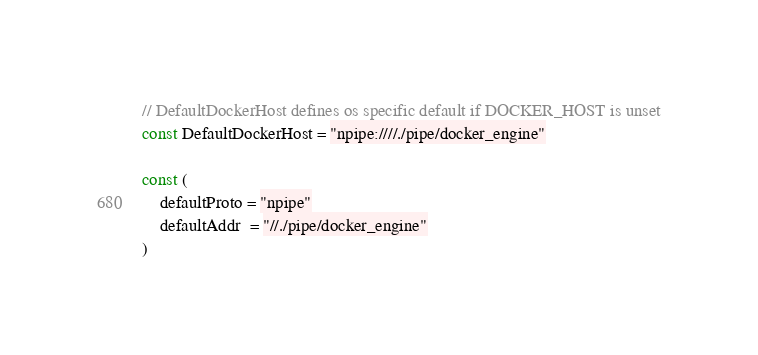<code> <loc_0><loc_0><loc_500><loc_500><_Go_>
// DefaultDockerHost defines os specific default if DOCKER_HOST is unset
const DefaultDockerHost = "npipe:////./pipe/docker_engine"

const (
	defaultProto = "npipe"
	defaultAddr  = "//./pipe/docker_engine"
)
</code> 